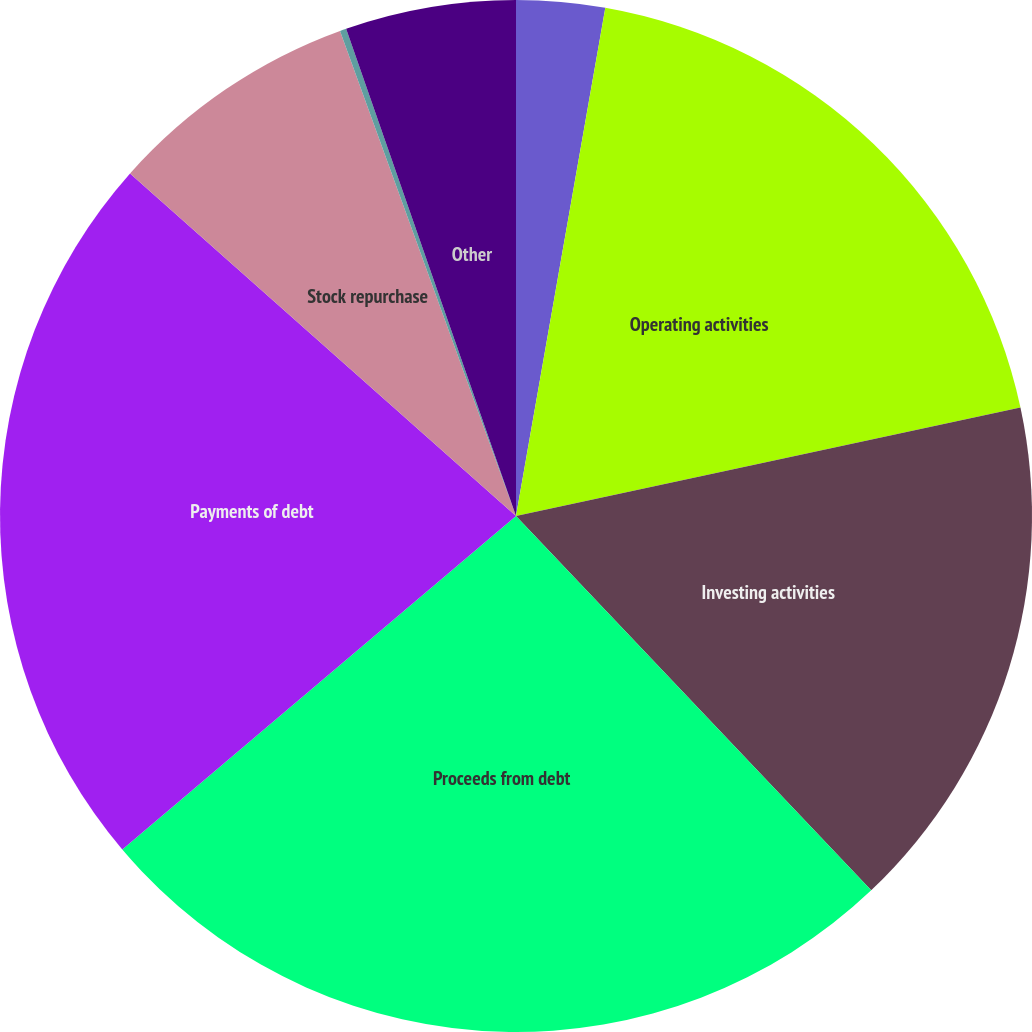<chart> <loc_0><loc_0><loc_500><loc_500><pie_chart><fcel>In thousands<fcel>Operating activities<fcel>Investing activities<fcel>Proceeds from debt<fcel>Payments of debt<fcel>Stock repurchase<fcel>Cash dividends<fcel>Other<nl><fcel>2.77%<fcel>18.86%<fcel>16.29%<fcel>25.9%<fcel>22.74%<fcel>7.91%<fcel>0.2%<fcel>5.34%<nl></chart> 